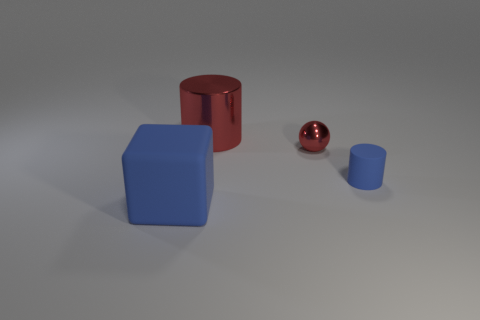How big is the blue matte object that is on the right side of the big blue cube?
Your answer should be very brief. Small. What is the small blue cylinder made of?
Provide a succinct answer. Rubber. What shape is the blue object that is to the right of the cylinder behind the small metal object?
Provide a succinct answer. Cylinder. What number of other things are there of the same shape as the big blue object?
Keep it short and to the point. 0. Are there any small objects to the left of the blue rubber cube?
Your answer should be very brief. No. The sphere has what color?
Give a very brief answer. Red. Do the small rubber object and the cylinder that is to the left of the tiny blue cylinder have the same color?
Offer a very short reply. No. Is there a metal cylinder of the same size as the ball?
Offer a very short reply. No. What size is the rubber cylinder that is the same color as the large rubber thing?
Offer a terse response. Small. What is the small thing to the right of the red shiny sphere made of?
Make the answer very short. Rubber. 